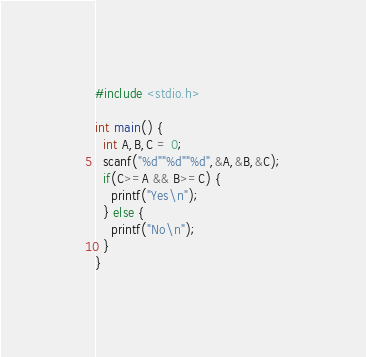<code> <loc_0><loc_0><loc_500><loc_500><_C_>#include <stdio.h>

int main() {
  int A,B,C = 0;
  scanf("%d""%d""%d",&A,&B,&C);
  if(C>=A && B>=C) {
    printf("Yes\n");
  } else {
    printf("No\n");
  }
}</code> 